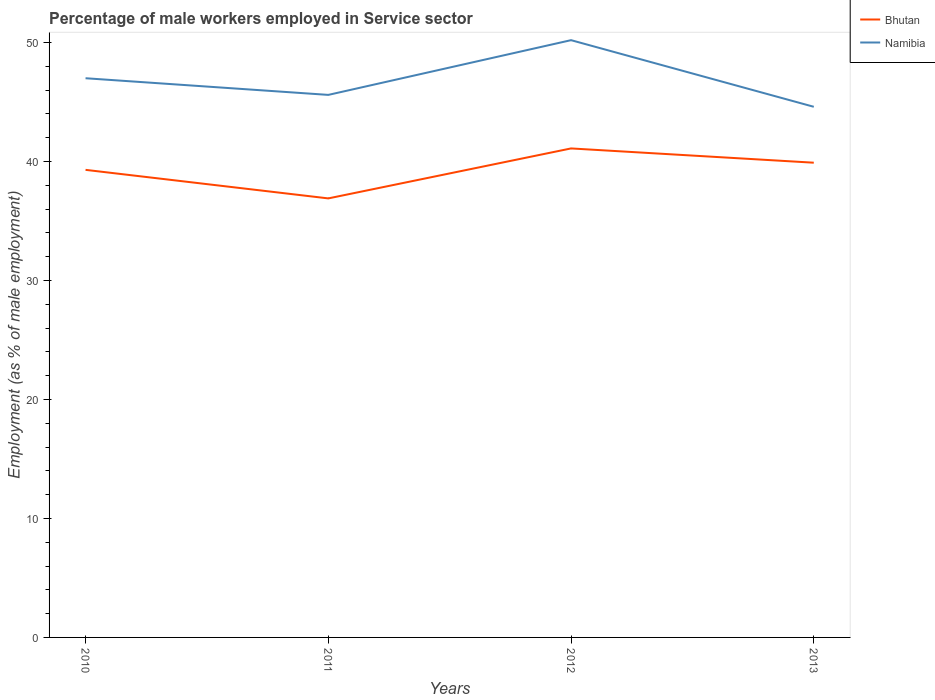How many different coloured lines are there?
Provide a succinct answer. 2. Across all years, what is the maximum percentage of male workers employed in Service sector in Bhutan?
Provide a short and direct response. 36.9. What is the difference between the highest and the second highest percentage of male workers employed in Service sector in Bhutan?
Offer a very short reply. 4.2. What is the difference between the highest and the lowest percentage of male workers employed in Service sector in Namibia?
Give a very brief answer. 2. Is the percentage of male workers employed in Service sector in Bhutan strictly greater than the percentage of male workers employed in Service sector in Namibia over the years?
Provide a succinct answer. Yes. How many lines are there?
Provide a short and direct response. 2. How many years are there in the graph?
Offer a terse response. 4. What is the difference between two consecutive major ticks on the Y-axis?
Give a very brief answer. 10. Does the graph contain grids?
Provide a short and direct response. No. What is the title of the graph?
Provide a short and direct response. Percentage of male workers employed in Service sector. What is the label or title of the Y-axis?
Offer a terse response. Employment (as % of male employment). What is the Employment (as % of male employment) in Bhutan in 2010?
Make the answer very short. 39.3. What is the Employment (as % of male employment) in Bhutan in 2011?
Offer a terse response. 36.9. What is the Employment (as % of male employment) of Namibia in 2011?
Your answer should be very brief. 45.6. What is the Employment (as % of male employment) in Bhutan in 2012?
Make the answer very short. 41.1. What is the Employment (as % of male employment) in Namibia in 2012?
Keep it short and to the point. 50.2. What is the Employment (as % of male employment) of Bhutan in 2013?
Keep it short and to the point. 39.9. What is the Employment (as % of male employment) of Namibia in 2013?
Offer a terse response. 44.6. Across all years, what is the maximum Employment (as % of male employment) of Bhutan?
Your response must be concise. 41.1. Across all years, what is the maximum Employment (as % of male employment) in Namibia?
Your answer should be very brief. 50.2. Across all years, what is the minimum Employment (as % of male employment) of Bhutan?
Your response must be concise. 36.9. Across all years, what is the minimum Employment (as % of male employment) of Namibia?
Provide a succinct answer. 44.6. What is the total Employment (as % of male employment) in Bhutan in the graph?
Ensure brevity in your answer.  157.2. What is the total Employment (as % of male employment) of Namibia in the graph?
Provide a succinct answer. 187.4. What is the difference between the Employment (as % of male employment) of Bhutan in 2010 and that in 2011?
Keep it short and to the point. 2.4. What is the difference between the Employment (as % of male employment) of Bhutan in 2010 and that in 2013?
Ensure brevity in your answer.  -0.6. What is the difference between the Employment (as % of male employment) in Namibia in 2010 and that in 2013?
Offer a very short reply. 2.4. What is the difference between the Employment (as % of male employment) in Namibia in 2011 and that in 2012?
Offer a very short reply. -4.6. What is the difference between the Employment (as % of male employment) in Namibia in 2012 and that in 2013?
Make the answer very short. 5.6. What is the difference between the Employment (as % of male employment) in Bhutan in 2010 and the Employment (as % of male employment) in Namibia in 2011?
Offer a very short reply. -6.3. What is the difference between the Employment (as % of male employment) of Bhutan in 2010 and the Employment (as % of male employment) of Namibia in 2012?
Offer a very short reply. -10.9. What is the difference between the Employment (as % of male employment) in Bhutan in 2011 and the Employment (as % of male employment) in Namibia in 2013?
Your response must be concise. -7.7. What is the difference between the Employment (as % of male employment) of Bhutan in 2012 and the Employment (as % of male employment) of Namibia in 2013?
Keep it short and to the point. -3.5. What is the average Employment (as % of male employment) in Bhutan per year?
Offer a terse response. 39.3. What is the average Employment (as % of male employment) of Namibia per year?
Your response must be concise. 46.85. In the year 2012, what is the difference between the Employment (as % of male employment) in Bhutan and Employment (as % of male employment) in Namibia?
Make the answer very short. -9.1. What is the ratio of the Employment (as % of male employment) in Bhutan in 2010 to that in 2011?
Ensure brevity in your answer.  1.06. What is the ratio of the Employment (as % of male employment) of Namibia in 2010 to that in 2011?
Make the answer very short. 1.03. What is the ratio of the Employment (as % of male employment) of Bhutan in 2010 to that in 2012?
Make the answer very short. 0.96. What is the ratio of the Employment (as % of male employment) of Namibia in 2010 to that in 2012?
Give a very brief answer. 0.94. What is the ratio of the Employment (as % of male employment) in Bhutan in 2010 to that in 2013?
Your response must be concise. 0.98. What is the ratio of the Employment (as % of male employment) of Namibia in 2010 to that in 2013?
Offer a terse response. 1.05. What is the ratio of the Employment (as % of male employment) of Bhutan in 2011 to that in 2012?
Keep it short and to the point. 0.9. What is the ratio of the Employment (as % of male employment) of Namibia in 2011 to that in 2012?
Give a very brief answer. 0.91. What is the ratio of the Employment (as % of male employment) of Bhutan in 2011 to that in 2013?
Your answer should be very brief. 0.92. What is the ratio of the Employment (as % of male employment) of Namibia in 2011 to that in 2013?
Your answer should be very brief. 1.02. What is the ratio of the Employment (as % of male employment) of Bhutan in 2012 to that in 2013?
Offer a very short reply. 1.03. What is the ratio of the Employment (as % of male employment) of Namibia in 2012 to that in 2013?
Offer a very short reply. 1.13. What is the difference between the highest and the second highest Employment (as % of male employment) of Bhutan?
Offer a terse response. 1.2. What is the difference between the highest and the second highest Employment (as % of male employment) in Namibia?
Provide a short and direct response. 3.2. 